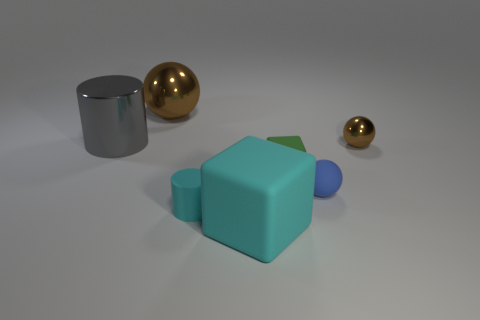How many brown metallic cylinders are there?
Your response must be concise. 0. What is the size of the cylinder in front of the tiny brown object?
Offer a terse response. Small. What number of gray metal balls have the same size as the cyan cylinder?
Keep it short and to the point. 0. What is the large thing that is both on the left side of the big cyan thing and to the right of the large gray metal cylinder made of?
Provide a short and direct response. Metal. There is a ball that is the same size as the gray metal cylinder; what is its material?
Make the answer very short. Metal. There is a matte sphere that is in front of the block behind the blue ball that is in front of the green rubber thing; what size is it?
Make the answer very short. Small. What is the size of the cyan block that is made of the same material as the small cyan thing?
Your answer should be very brief. Large. There is a blue object; is it the same size as the brown shiny object right of the blue ball?
Your answer should be compact. Yes. There is a rubber object on the left side of the large rubber cube; what shape is it?
Your answer should be very brief. Cylinder. Are there any tiny cyan cylinders to the right of the ball that is left of the tiny cyan rubber thing that is left of the small brown metallic sphere?
Provide a short and direct response. Yes. 